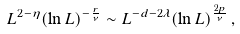Convert formula to latex. <formula><loc_0><loc_0><loc_500><loc_500>L ^ { 2 - \eta } ( \ln { L } ) ^ { - \frac { r } { \nu } } \sim L ^ { - d - 2 \lambda } ( \ln { L } ) ^ { \frac { 2 p } { \nu } } \, ,</formula> 